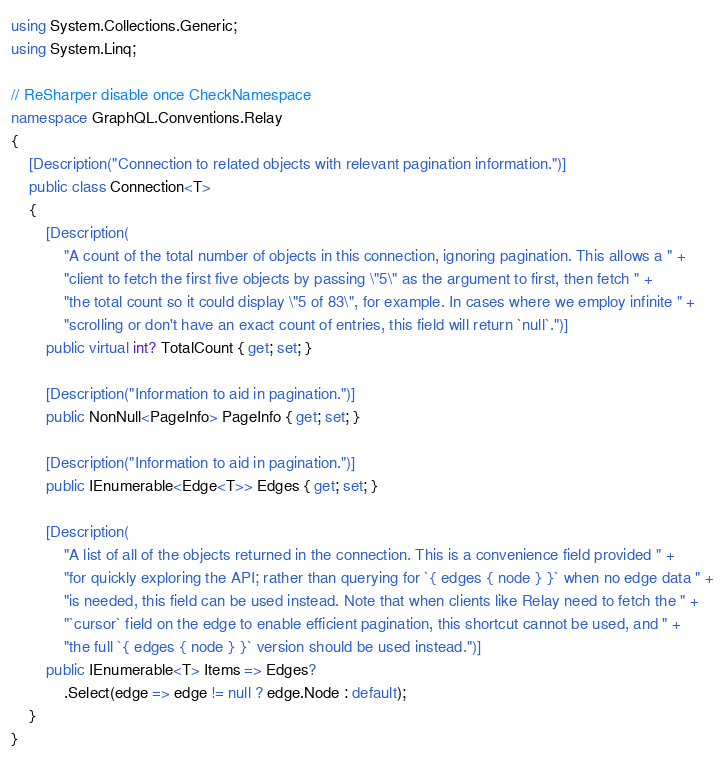Convert code to text. <code><loc_0><loc_0><loc_500><loc_500><_C#_>using System.Collections.Generic;
using System.Linq;

// ReSharper disable once CheckNamespace
namespace GraphQL.Conventions.Relay
{
    [Description("Connection to related objects with relevant pagination information.")]
    public class Connection<T>
    {
        [Description(
            "A count of the total number of objects in this connection, ignoring pagination. This allows a " +
            "client to fetch the first five objects by passing \"5\" as the argument to first, then fetch " +
            "the total count so it could display \"5 of 83\", for example. In cases where we employ infinite " +
            "scrolling or don't have an exact count of entries, this field will return `null`.")]
        public virtual int? TotalCount { get; set; }

        [Description("Information to aid in pagination.")]
        public NonNull<PageInfo> PageInfo { get; set; }

        [Description("Information to aid in pagination.")]
        public IEnumerable<Edge<T>> Edges { get; set; }

        [Description(
            "A list of all of the objects returned in the connection. This is a convenience field provided " +
            "for quickly exploring the API; rather than querying for `{ edges { node } }` when no edge data " +
            "is needed, this field can be used instead. Note that when clients like Relay need to fetch the " +
            "`cursor` field on the edge to enable efficient pagination, this shortcut cannot be used, and " +
            "the full `{ edges { node } }` version should be used instead.")]
        public IEnumerable<T> Items => Edges?
            .Select(edge => edge != null ? edge.Node : default);
    }
}
</code> 